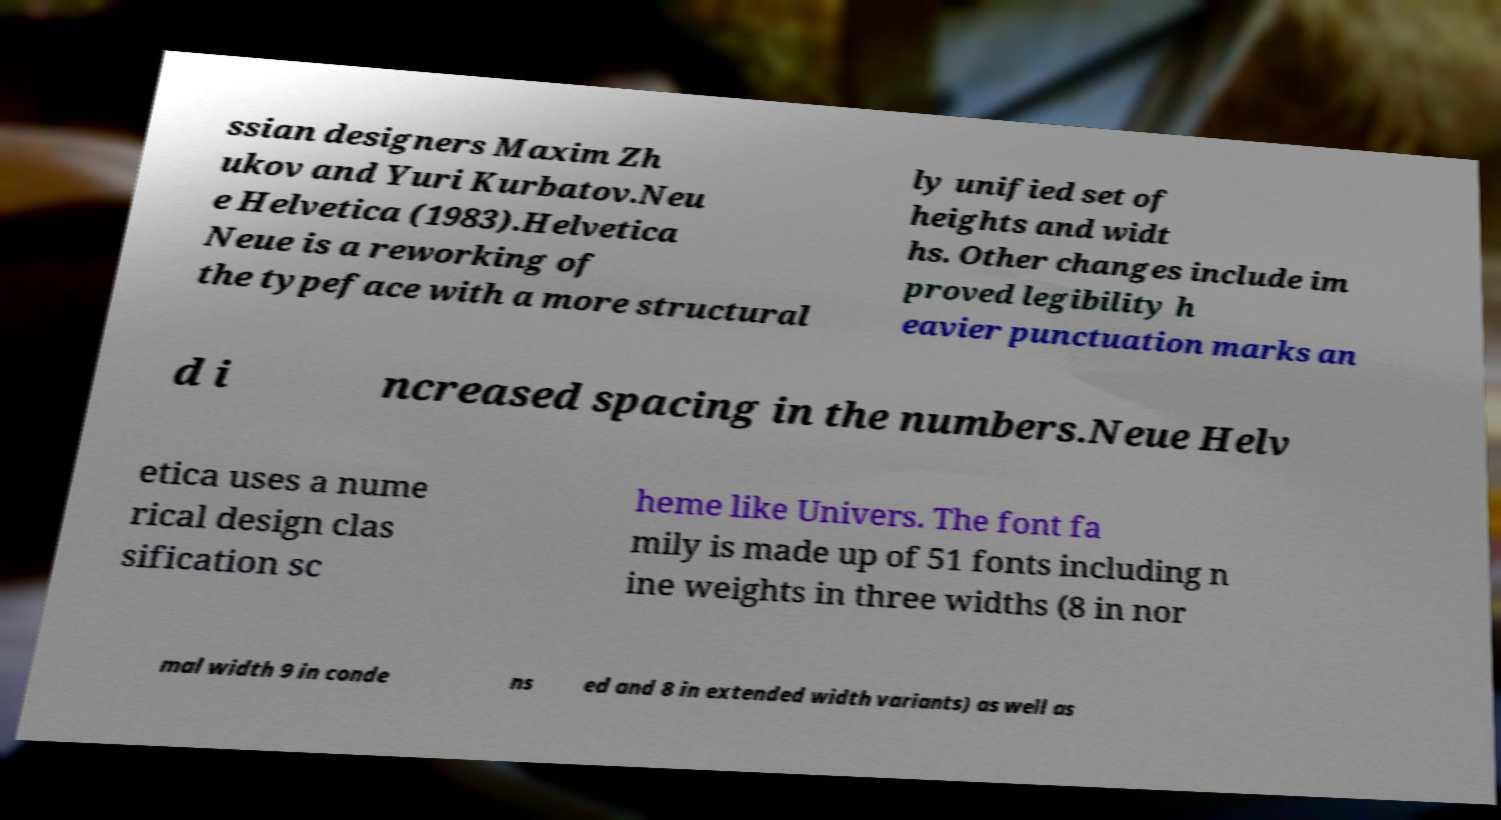Could you extract and type out the text from this image? ssian designers Maxim Zh ukov and Yuri Kurbatov.Neu e Helvetica (1983).Helvetica Neue is a reworking of the typeface with a more structural ly unified set of heights and widt hs. Other changes include im proved legibility h eavier punctuation marks an d i ncreased spacing in the numbers.Neue Helv etica uses a nume rical design clas sification sc heme like Univers. The font fa mily is made up of 51 fonts including n ine weights in three widths (8 in nor mal width 9 in conde ns ed and 8 in extended width variants) as well as 